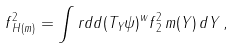Convert formula to latex. <formula><loc_0><loc_0><loc_500><loc_500>\| f \| _ { H ( m ) } ^ { 2 } = \int r d d \| ( T _ { Y } \psi ) ^ { w } f \| _ { 2 } ^ { 2 } \, m ( Y ) \, d Y \, ,</formula> 